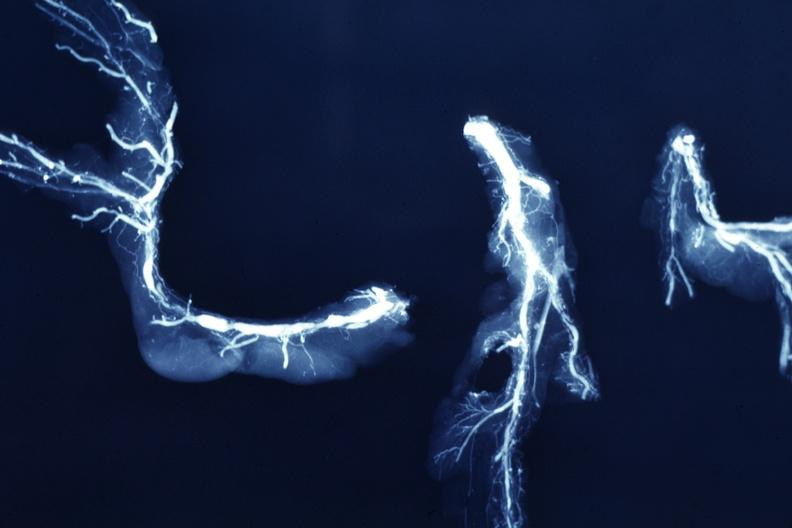s retroperitoneal liposarcoma present?
Answer the question using a single word or phrase. No 